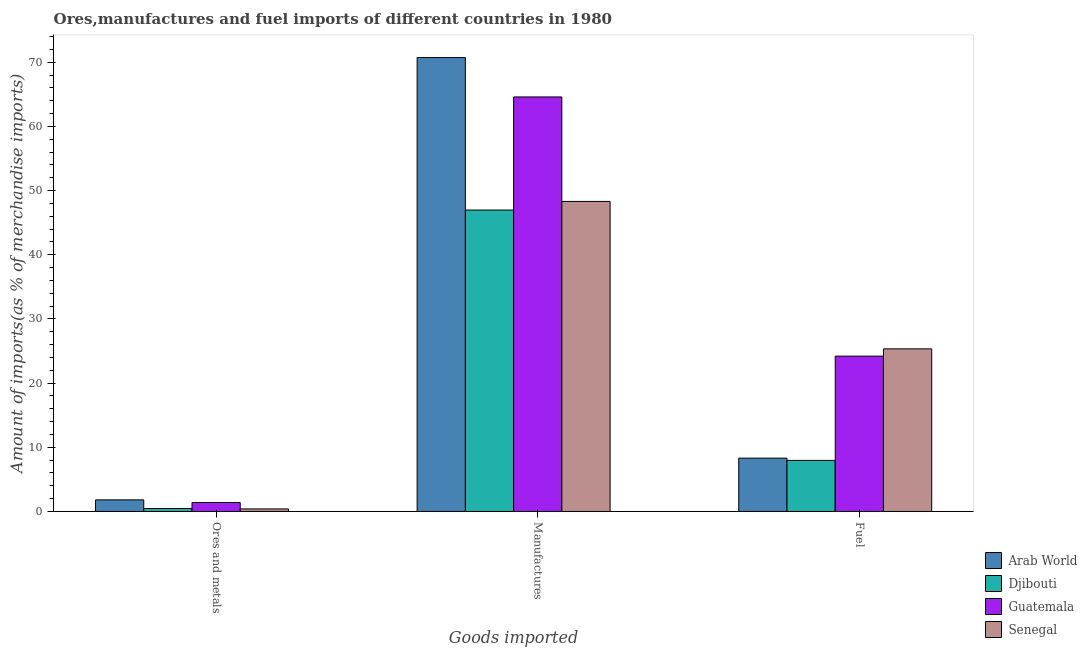How many different coloured bars are there?
Provide a succinct answer. 4. How many groups of bars are there?
Make the answer very short. 3. How many bars are there on the 3rd tick from the left?
Your response must be concise. 4. What is the label of the 1st group of bars from the left?
Your answer should be compact. Ores and metals. What is the percentage of ores and metals imports in Arab World?
Your answer should be compact. 1.81. Across all countries, what is the maximum percentage of manufactures imports?
Make the answer very short. 70.73. Across all countries, what is the minimum percentage of fuel imports?
Your response must be concise. 7.96. In which country was the percentage of ores and metals imports maximum?
Offer a terse response. Arab World. In which country was the percentage of fuel imports minimum?
Your answer should be very brief. Djibouti. What is the total percentage of manufactures imports in the graph?
Provide a succinct answer. 230.61. What is the difference between the percentage of ores and metals imports in Guatemala and that in Senegal?
Ensure brevity in your answer.  1. What is the difference between the percentage of fuel imports in Senegal and the percentage of manufactures imports in Djibouti?
Your answer should be very brief. -21.63. What is the average percentage of fuel imports per country?
Your answer should be compact. 16.45. What is the difference between the percentage of ores and metals imports and percentage of manufactures imports in Guatemala?
Provide a short and direct response. -63.19. What is the ratio of the percentage of ores and metals imports in Djibouti to that in Senegal?
Keep it short and to the point. 1.16. What is the difference between the highest and the second highest percentage of ores and metals imports?
Your response must be concise. 0.41. What is the difference between the highest and the lowest percentage of manufactures imports?
Ensure brevity in your answer.  23.76. In how many countries, is the percentage of ores and metals imports greater than the average percentage of ores and metals imports taken over all countries?
Keep it short and to the point. 2. Is the sum of the percentage of manufactures imports in Guatemala and Senegal greater than the maximum percentage of ores and metals imports across all countries?
Ensure brevity in your answer.  Yes. What does the 2nd bar from the left in Fuel represents?
Provide a succinct answer. Djibouti. What does the 4th bar from the right in Ores and metals represents?
Your response must be concise. Arab World. Are all the bars in the graph horizontal?
Give a very brief answer. No. How many countries are there in the graph?
Make the answer very short. 4. Are the values on the major ticks of Y-axis written in scientific E-notation?
Give a very brief answer. No. Does the graph contain any zero values?
Offer a very short reply. No. Does the graph contain grids?
Your answer should be compact. No. Where does the legend appear in the graph?
Offer a very short reply. Bottom right. How are the legend labels stacked?
Provide a succinct answer. Vertical. What is the title of the graph?
Make the answer very short. Ores,manufactures and fuel imports of different countries in 1980. What is the label or title of the X-axis?
Ensure brevity in your answer.  Goods imported. What is the label or title of the Y-axis?
Offer a very short reply. Amount of imports(as % of merchandise imports). What is the Amount of imports(as % of merchandise imports) of Arab World in Ores and metals?
Keep it short and to the point. 1.81. What is the Amount of imports(as % of merchandise imports) in Djibouti in Ores and metals?
Give a very brief answer. 0.46. What is the Amount of imports(as % of merchandise imports) in Guatemala in Ores and metals?
Your answer should be compact. 1.4. What is the Amount of imports(as % of merchandise imports) in Senegal in Ores and metals?
Provide a succinct answer. 0.4. What is the Amount of imports(as % of merchandise imports) of Arab World in Manufactures?
Your answer should be compact. 70.73. What is the Amount of imports(as % of merchandise imports) of Djibouti in Manufactures?
Give a very brief answer. 46.97. What is the Amount of imports(as % of merchandise imports) in Guatemala in Manufactures?
Give a very brief answer. 64.59. What is the Amount of imports(as % of merchandise imports) of Senegal in Manufactures?
Your answer should be compact. 48.31. What is the Amount of imports(as % of merchandise imports) in Arab World in Fuel?
Give a very brief answer. 8.31. What is the Amount of imports(as % of merchandise imports) in Djibouti in Fuel?
Offer a terse response. 7.96. What is the Amount of imports(as % of merchandise imports) of Guatemala in Fuel?
Your answer should be compact. 24.21. What is the Amount of imports(as % of merchandise imports) in Senegal in Fuel?
Ensure brevity in your answer.  25.34. Across all Goods imported, what is the maximum Amount of imports(as % of merchandise imports) in Arab World?
Give a very brief answer. 70.73. Across all Goods imported, what is the maximum Amount of imports(as % of merchandise imports) of Djibouti?
Provide a short and direct response. 46.97. Across all Goods imported, what is the maximum Amount of imports(as % of merchandise imports) in Guatemala?
Offer a very short reply. 64.59. Across all Goods imported, what is the maximum Amount of imports(as % of merchandise imports) of Senegal?
Your answer should be very brief. 48.31. Across all Goods imported, what is the minimum Amount of imports(as % of merchandise imports) in Arab World?
Keep it short and to the point. 1.81. Across all Goods imported, what is the minimum Amount of imports(as % of merchandise imports) of Djibouti?
Your answer should be compact. 0.46. Across all Goods imported, what is the minimum Amount of imports(as % of merchandise imports) of Guatemala?
Ensure brevity in your answer.  1.4. Across all Goods imported, what is the minimum Amount of imports(as % of merchandise imports) in Senegal?
Offer a terse response. 0.4. What is the total Amount of imports(as % of merchandise imports) of Arab World in the graph?
Offer a very short reply. 80.85. What is the total Amount of imports(as % of merchandise imports) in Djibouti in the graph?
Give a very brief answer. 55.39. What is the total Amount of imports(as % of merchandise imports) in Guatemala in the graph?
Your answer should be very brief. 90.2. What is the total Amount of imports(as % of merchandise imports) of Senegal in the graph?
Provide a short and direct response. 74.05. What is the difference between the Amount of imports(as % of merchandise imports) in Arab World in Ores and metals and that in Manufactures?
Provide a short and direct response. -68.92. What is the difference between the Amount of imports(as % of merchandise imports) of Djibouti in Ores and metals and that in Manufactures?
Keep it short and to the point. -46.51. What is the difference between the Amount of imports(as % of merchandise imports) in Guatemala in Ores and metals and that in Manufactures?
Provide a succinct answer. -63.19. What is the difference between the Amount of imports(as % of merchandise imports) in Senegal in Ores and metals and that in Manufactures?
Ensure brevity in your answer.  -47.92. What is the difference between the Amount of imports(as % of merchandise imports) of Arab World in Ores and metals and that in Fuel?
Make the answer very short. -6.5. What is the difference between the Amount of imports(as % of merchandise imports) in Guatemala in Ores and metals and that in Fuel?
Your answer should be compact. -22.81. What is the difference between the Amount of imports(as % of merchandise imports) of Senegal in Ores and metals and that in Fuel?
Ensure brevity in your answer.  -24.94. What is the difference between the Amount of imports(as % of merchandise imports) of Arab World in Manufactures and that in Fuel?
Ensure brevity in your answer.  62.42. What is the difference between the Amount of imports(as % of merchandise imports) in Djibouti in Manufactures and that in Fuel?
Provide a short and direct response. 39.01. What is the difference between the Amount of imports(as % of merchandise imports) of Guatemala in Manufactures and that in Fuel?
Provide a short and direct response. 40.39. What is the difference between the Amount of imports(as % of merchandise imports) of Senegal in Manufactures and that in Fuel?
Ensure brevity in your answer.  22.97. What is the difference between the Amount of imports(as % of merchandise imports) of Arab World in Ores and metals and the Amount of imports(as % of merchandise imports) of Djibouti in Manufactures?
Offer a terse response. -45.16. What is the difference between the Amount of imports(as % of merchandise imports) in Arab World in Ores and metals and the Amount of imports(as % of merchandise imports) in Guatemala in Manufactures?
Keep it short and to the point. -62.78. What is the difference between the Amount of imports(as % of merchandise imports) of Arab World in Ores and metals and the Amount of imports(as % of merchandise imports) of Senegal in Manufactures?
Your response must be concise. -46.5. What is the difference between the Amount of imports(as % of merchandise imports) in Djibouti in Ores and metals and the Amount of imports(as % of merchandise imports) in Guatemala in Manufactures?
Offer a very short reply. -64.13. What is the difference between the Amount of imports(as % of merchandise imports) in Djibouti in Ores and metals and the Amount of imports(as % of merchandise imports) in Senegal in Manufactures?
Offer a terse response. -47.85. What is the difference between the Amount of imports(as % of merchandise imports) of Guatemala in Ores and metals and the Amount of imports(as % of merchandise imports) of Senegal in Manufactures?
Provide a succinct answer. -46.91. What is the difference between the Amount of imports(as % of merchandise imports) of Arab World in Ores and metals and the Amount of imports(as % of merchandise imports) of Djibouti in Fuel?
Make the answer very short. -6.15. What is the difference between the Amount of imports(as % of merchandise imports) in Arab World in Ores and metals and the Amount of imports(as % of merchandise imports) in Guatemala in Fuel?
Your answer should be very brief. -22.4. What is the difference between the Amount of imports(as % of merchandise imports) of Arab World in Ores and metals and the Amount of imports(as % of merchandise imports) of Senegal in Fuel?
Your response must be concise. -23.53. What is the difference between the Amount of imports(as % of merchandise imports) in Djibouti in Ores and metals and the Amount of imports(as % of merchandise imports) in Guatemala in Fuel?
Your answer should be very brief. -23.75. What is the difference between the Amount of imports(as % of merchandise imports) of Djibouti in Ores and metals and the Amount of imports(as % of merchandise imports) of Senegal in Fuel?
Provide a succinct answer. -24.88. What is the difference between the Amount of imports(as % of merchandise imports) in Guatemala in Ores and metals and the Amount of imports(as % of merchandise imports) in Senegal in Fuel?
Your answer should be compact. -23.94. What is the difference between the Amount of imports(as % of merchandise imports) in Arab World in Manufactures and the Amount of imports(as % of merchandise imports) in Djibouti in Fuel?
Your answer should be compact. 62.77. What is the difference between the Amount of imports(as % of merchandise imports) in Arab World in Manufactures and the Amount of imports(as % of merchandise imports) in Guatemala in Fuel?
Your response must be concise. 46.52. What is the difference between the Amount of imports(as % of merchandise imports) in Arab World in Manufactures and the Amount of imports(as % of merchandise imports) in Senegal in Fuel?
Provide a succinct answer. 45.39. What is the difference between the Amount of imports(as % of merchandise imports) in Djibouti in Manufactures and the Amount of imports(as % of merchandise imports) in Guatemala in Fuel?
Make the answer very short. 22.76. What is the difference between the Amount of imports(as % of merchandise imports) in Djibouti in Manufactures and the Amount of imports(as % of merchandise imports) in Senegal in Fuel?
Your answer should be compact. 21.63. What is the difference between the Amount of imports(as % of merchandise imports) in Guatemala in Manufactures and the Amount of imports(as % of merchandise imports) in Senegal in Fuel?
Keep it short and to the point. 39.25. What is the average Amount of imports(as % of merchandise imports) of Arab World per Goods imported?
Provide a succinct answer. 26.95. What is the average Amount of imports(as % of merchandise imports) in Djibouti per Goods imported?
Ensure brevity in your answer.  18.46. What is the average Amount of imports(as % of merchandise imports) of Guatemala per Goods imported?
Provide a short and direct response. 30.07. What is the average Amount of imports(as % of merchandise imports) in Senegal per Goods imported?
Your answer should be very brief. 24.68. What is the difference between the Amount of imports(as % of merchandise imports) of Arab World and Amount of imports(as % of merchandise imports) of Djibouti in Ores and metals?
Your answer should be compact. 1.35. What is the difference between the Amount of imports(as % of merchandise imports) in Arab World and Amount of imports(as % of merchandise imports) in Guatemala in Ores and metals?
Give a very brief answer. 0.41. What is the difference between the Amount of imports(as % of merchandise imports) in Arab World and Amount of imports(as % of merchandise imports) in Senegal in Ores and metals?
Provide a short and direct response. 1.41. What is the difference between the Amount of imports(as % of merchandise imports) of Djibouti and Amount of imports(as % of merchandise imports) of Guatemala in Ores and metals?
Provide a short and direct response. -0.94. What is the difference between the Amount of imports(as % of merchandise imports) in Djibouti and Amount of imports(as % of merchandise imports) in Senegal in Ores and metals?
Give a very brief answer. 0.06. What is the difference between the Amount of imports(as % of merchandise imports) of Guatemala and Amount of imports(as % of merchandise imports) of Senegal in Ores and metals?
Give a very brief answer. 1. What is the difference between the Amount of imports(as % of merchandise imports) of Arab World and Amount of imports(as % of merchandise imports) of Djibouti in Manufactures?
Give a very brief answer. 23.76. What is the difference between the Amount of imports(as % of merchandise imports) in Arab World and Amount of imports(as % of merchandise imports) in Guatemala in Manufactures?
Your answer should be very brief. 6.14. What is the difference between the Amount of imports(as % of merchandise imports) in Arab World and Amount of imports(as % of merchandise imports) in Senegal in Manufactures?
Provide a short and direct response. 22.42. What is the difference between the Amount of imports(as % of merchandise imports) of Djibouti and Amount of imports(as % of merchandise imports) of Guatemala in Manufactures?
Ensure brevity in your answer.  -17.62. What is the difference between the Amount of imports(as % of merchandise imports) of Djibouti and Amount of imports(as % of merchandise imports) of Senegal in Manufactures?
Give a very brief answer. -1.34. What is the difference between the Amount of imports(as % of merchandise imports) of Guatemala and Amount of imports(as % of merchandise imports) of Senegal in Manufactures?
Give a very brief answer. 16.28. What is the difference between the Amount of imports(as % of merchandise imports) of Arab World and Amount of imports(as % of merchandise imports) of Djibouti in Fuel?
Provide a succinct answer. 0.35. What is the difference between the Amount of imports(as % of merchandise imports) in Arab World and Amount of imports(as % of merchandise imports) in Guatemala in Fuel?
Ensure brevity in your answer.  -15.9. What is the difference between the Amount of imports(as % of merchandise imports) of Arab World and Amount of imports(as % of merchandise imports) of Senegal in Fuel?
Your response must be concise. -17.03. What is the difference between the Amount of imports(as % of merchandise imports) in Djibouti and Amount of imports(as % of merchandise imports) in Guatemala in Fuel?
Provide a succinct answer. -16.25. What is the difference between the Amount of imports(as % of merchandise imports) of Djibouti and Amount of imports(as % of merchandise imports) of Senegal in Fuel?
Provide a short and direct response. -17.38. What is the difference between the Amount of imports(as % of merchandise imports) in Guatemala and Amount of imports(as % of merchandise imports) in Senegal in Fuel?
Keep it short and to the point. -1.13. What is the ratio of the Amount of imports(as % of merchandise imports) of Arab World in Ores and metals to that in Manufactures?
Your answer should be very brief. 0.03. What is the ratio of the Amount of imports(as % of merchandise imports) in Djibouti in Ores and metals to that in Manufactures?
Offer a very short reply. 0.01. What is the ratio of the Amount of imports(as % of merchandise imports) of Guatemala in Ores and metals to that in Manufactures?
Your answer should be very brief. 0.02. What is the ratio of the Amount of imports(as % of merchandise imports) of Senegal in Ores and metals to that in Manufactures?
Ensure brevity in your answer.  0.01. What is the ratio of the Amount of imports(as % of merchandise imports) in Arab World in Ores and metals to that in Fuel?
Provide a succinct answer. 0.22. What is the ratio of the Amount of imports(as % of merchandise imports) of Djibouti in Ores and metals to that in Fuel?
Offer a very short reply. 0.06. What is the ratio of the Amount of imports(as % of merchandise imports) of Guatemala in Ores and metals to that in Fuel?
Make the answer very short. 0.06. What is the ratio of the Amount of imports(as % of merchandise imports) of Senegal in Ores and metals to that in Fuel?
Offer a terse response. 0.02. What is the ratio of the Amount of imports(as % of merchandise imports) of Arab World in Manufactures to that in Fuel?
Ensure brevity in your answer.  8.51. What is the ratio of the Amount of imports(as % of merchandise imports) in Djibouti in Manufactures to that in Fuel?
Give a very brief answer. 5.9. What is the ratio of the Amount of imports(as % of merchandise imports) of Guatemala in Manufactures to that in Fuel?
Your answer should be very brief. 2.67. What is the ratio of the Amount of imports(as % of merchandise imports) in Senegal in Manufactures to that in Fuel?
Make the answer very short. 1.91. What is the difference between the highest and the second highest Amount of imports(as % of merchandise imports) in Arab World?
Your answer should be compact. 62.42. What is the difference between the highest and the second highest Amount of imports(as % of merchandise imports) of Djibouti?
Offer a very short reply. 39.01. What is the difference between the highest and the second highest Amount of imports(as % of merchandise imports) of Guatemala?
Offer a very short reply. 40.39. What is the difference between the highest and the second highest Amount of imports(as % of merchandise imports) in Senegal?
Keep it short and to the point. 22.97. What is the difference between the highest and the lowest Amount of imports(as % of merchandise imports) in Arab World?
Make the answer very short. 68.92. What is the difference between the highest and the lowest Amount of imports(as % of merchandise imports) in Djibouti?
Offer a terse response. 46.51. What is the difference between the highest and the lowest Amount of imports(as % of merchandise imports) in Guatemala?
Provide a short and direct response. 63.19. What is the difference between the highest and the lowest Amount of imports(as % of merchandise imports) in Senegal?
Provide a short and direct response. 47.92. 